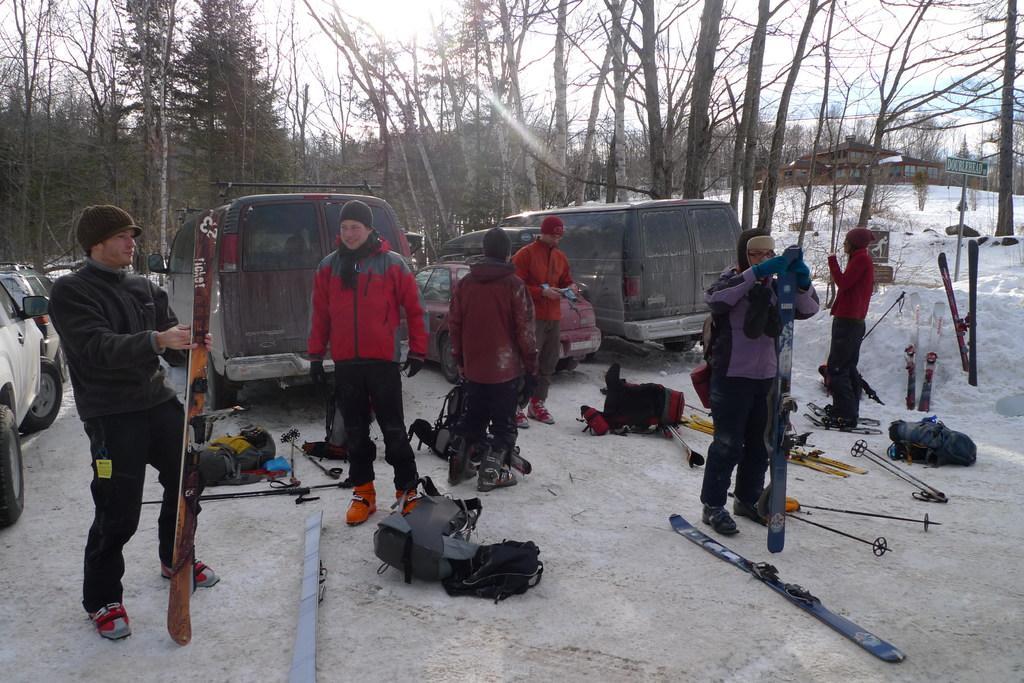Can you describe this image briefly? In the image we can see few persons were standing and holding some object. In the background there is a sky with clouds,trees,vehicles,snow and backpacks. 